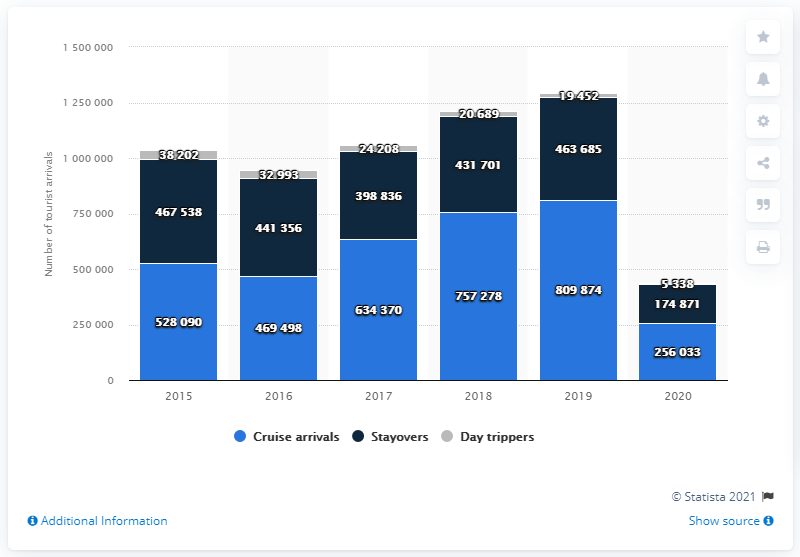Identify some key points in this picture. In 2020, a total of 174,871 tourists stayed overnight in Curaçao. The number of cruise arrivals in Curaçao in 2020 was 256,033. 